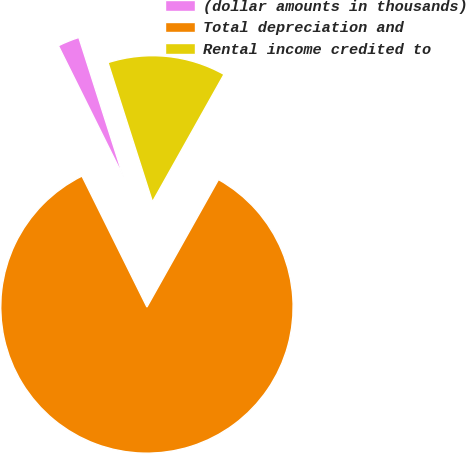Convert chart. <chart><loc_0><loc_0><loc_500><loc_500><pie_chart><fcel>(dollar amounts in thousands)<fcel>Total depreciation and<fcel>Rental income credited to<nl><fcel>2.41%<fcel>84.53%<fcel>13.06%<nl></chart> 